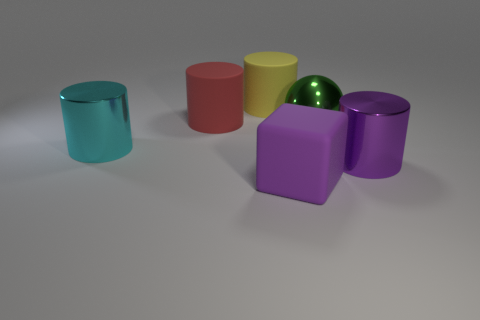Is the number of big objects greater than the number of big spheres?
Ensure brevity in your answer.  Yes. The metal thing left of the large purple thing in front of the purple thing behind the big matte block is what color?
Keep it short and to the point. Cyan. Is the color of the big cylinder in front of the cyan shiny object the same as the matte thing that is in front of the purple shiny cylinder?
Ensure brevity in your answer.  Yes. There is a metal thing that is on the left side of the purple matte block; how many big cyan things are in front of it?
Offer a very short reply. 0. Are any big gray matte spheres visible?
Your answer should be compact. No. What number of other objects are the same color as the big shiny ball?
Provide a short and direct response. 0. Are there fewer big matte blocks than yellow metal objects?
Provide a succinct answer. No. The metal thing in front of the shiny thing to the left of the large purple rubber block is what shape?
Offer a terse response. Cylinder. There is a cyan thing; are there any big rubber objects in front of it?
Your answer should be compact. Yes. There is a rubber cube that is the same size as the purple shiny object; what color is it?
Keep it short and to the point. Purple. 